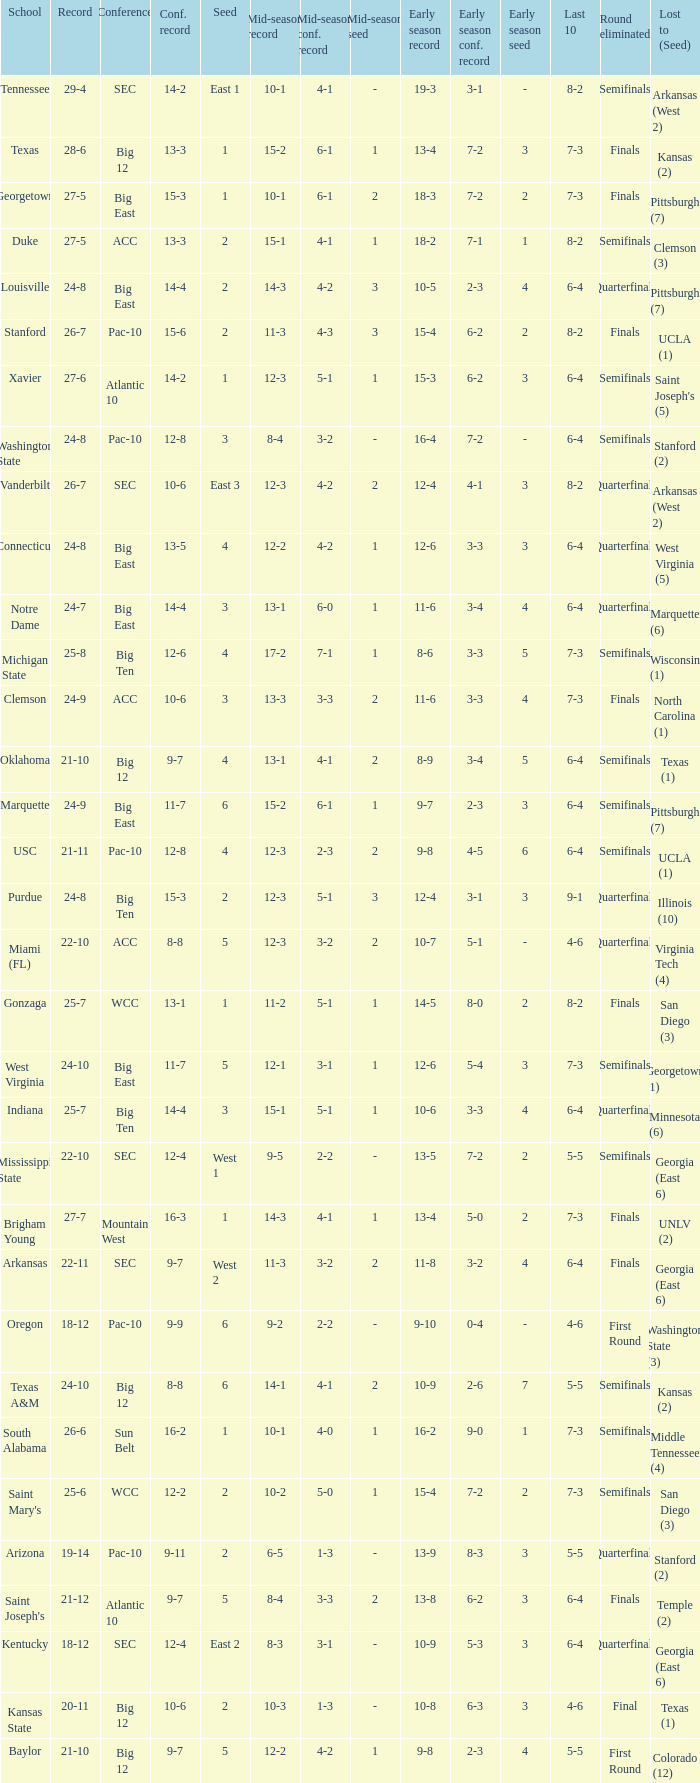Name the school where conference record is 12-6 Michigan State. 